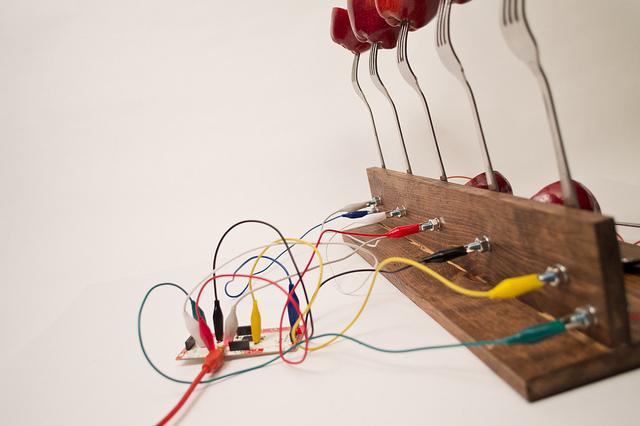What is this machine going to do?
Short answer required. Create electricity. What is on the forks?
Write a very short answer. Apples. How many plugs are on the board?
Quick response, please. 6. 